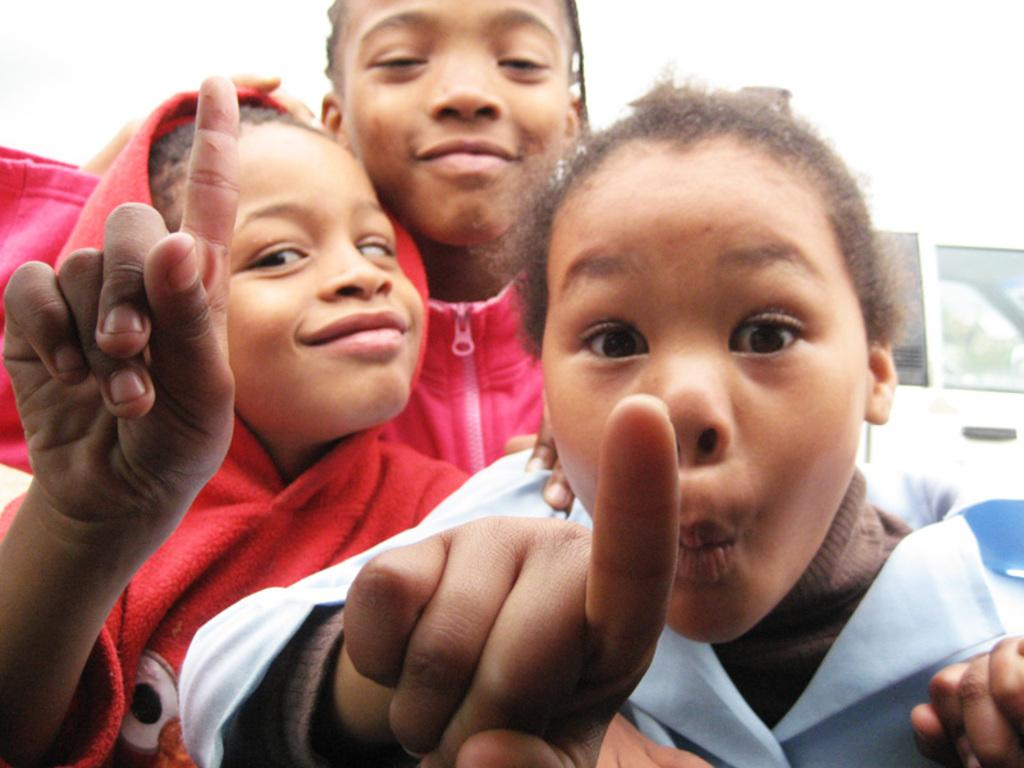How many kids are present in the image? There are three kids in the image. What are the expressions of the kids like? The kids are giving weird expressions. What are the kids doing with their hands? Two of the kids are pointing their fingers. What can be seen in the background of the image? There is a wall in the background of the image. What type of powder is being used by the kids in the image? There is no powder present in the image; the kids are simply giving weird expressions and pointing their fingers. 